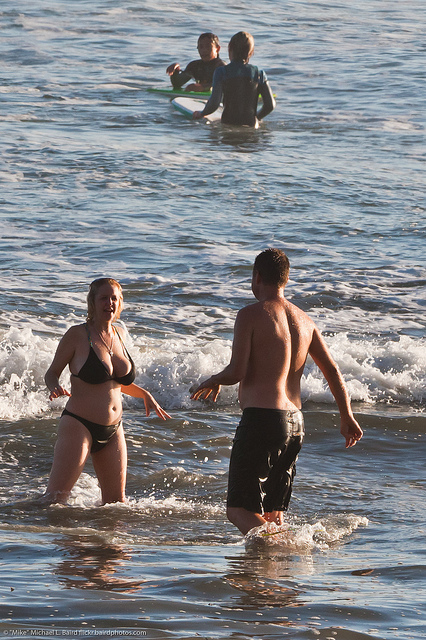What kind of water activity is happening in the background? In the background, there are two individuals who appear to be swimming in the ocean, potentially with a floatation device aiding them. 